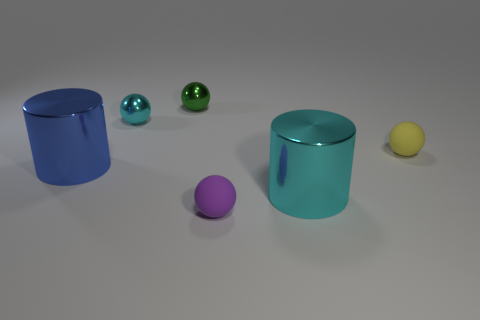Is the shape of the tiny cyan shiny object the same as the big cyan shiny thing?
Keep it short and to the point. No. What material is the purple ball?
Give a very brief answer. Rubber. How many small objects are to the right of the small cyan sphere and behind the yellow matte sphere?
Give a very brief answer. 1. Is the yellow rubber object the same size as the blue metal cylinder?
Provide a succinct answer. No. Do the cylinder that is on the left side of the green metal sphere and the tiny yellow object have the same size?
Your answer should be compact. No. There is a matte sphere that is in front of the blue cylinder; what is its color?
Your answer should be compact. Purple. What number of tiny green metallic spheres are there?
Ensure brevity in your answer.  1. There is a small thing that is made of the same material as the green ball; what shape is it?
Your answer should be compact. Sphere. There is a large metal object to the left of the tiny purple rubber object; is it the same color as the matte ball that is behind the large cyan shiny thing?
Provide a short and direct response. No. Is the number of large cyan objects behind the yellow rubber thing the same as the number of small cyan metallic balls?
Your answer should be very brief. No. 